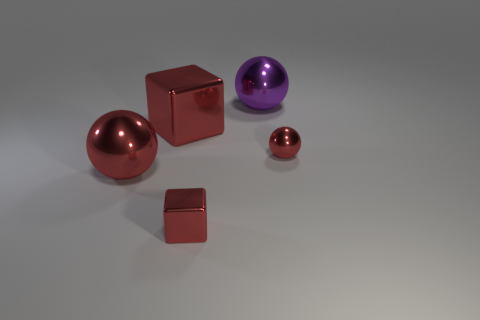What number of small metallic balls are behind the small red metallic cube in front of the big red shiny sphere? 1 